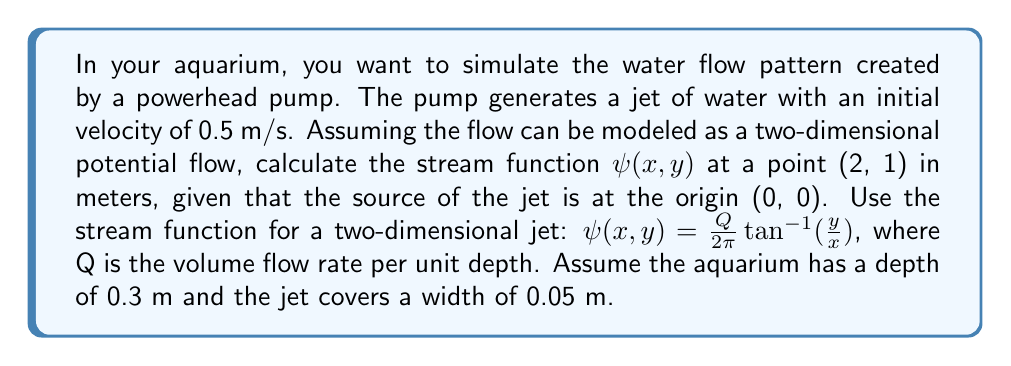Give your solution to this math problem. To solve this problem, we'll follow these steps:

1) First, we need to calculate the volume flow rate Q. We can do this using the initial velocity and the cross-sectional area of the jet.

   $Q = v * A$
   
   where v is the velocity (0.5 m/s) and A is the cross-sectional area.

2) The cross-sectional area is the width of the jet multiplied by the depth of the aquarium:

   $A = 0.05 \text{ m} * 0.3 \text{ m} = 0.015 \text{ m}^2$

3) Now we can calculate Q:

   $Q = 0.5 \text{ m/s} * 0.015 \text{ m}^2 = 0.0075 \text{ m}^3/\text{s}$

4) We have the stream function equation:

   $\psi(x,y) = \frac{Q}{2\pi} \tan^{-1}(\frac{y}{x})$

5) We need to calculate this at the point (2, 1). Let's substitute our values:

   $\psi(2,1) = \frac{0.0075}{2\pi} \tan^{-1}(\frac{1}{2})$

6) Let's calculate this step by step:
   
   $\tan^{-1}(\frac{1}{2}) \approx 0.4636 \text{ radians}$
   
   $\frac{0.0075}{2\pi} \approx 0.001193$

   $\psi(2,1) = 0.001193 * 0.4636 \approx 0.0005532 \text{ m}^2/\text{s}$

Therefore, the stream function $\psi(2,1)$ is approximately 0.0005532 $\text{m}^2/\text{s}$.
Answer: $0.0005532 \text{ m}^2/\text{s}$ 